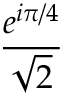<formula> <loc_0><loc_0><loc_500><loc_500>\frac { e ^ { i \pi / 4 } } { \sqrt { 2 } }</formula> 